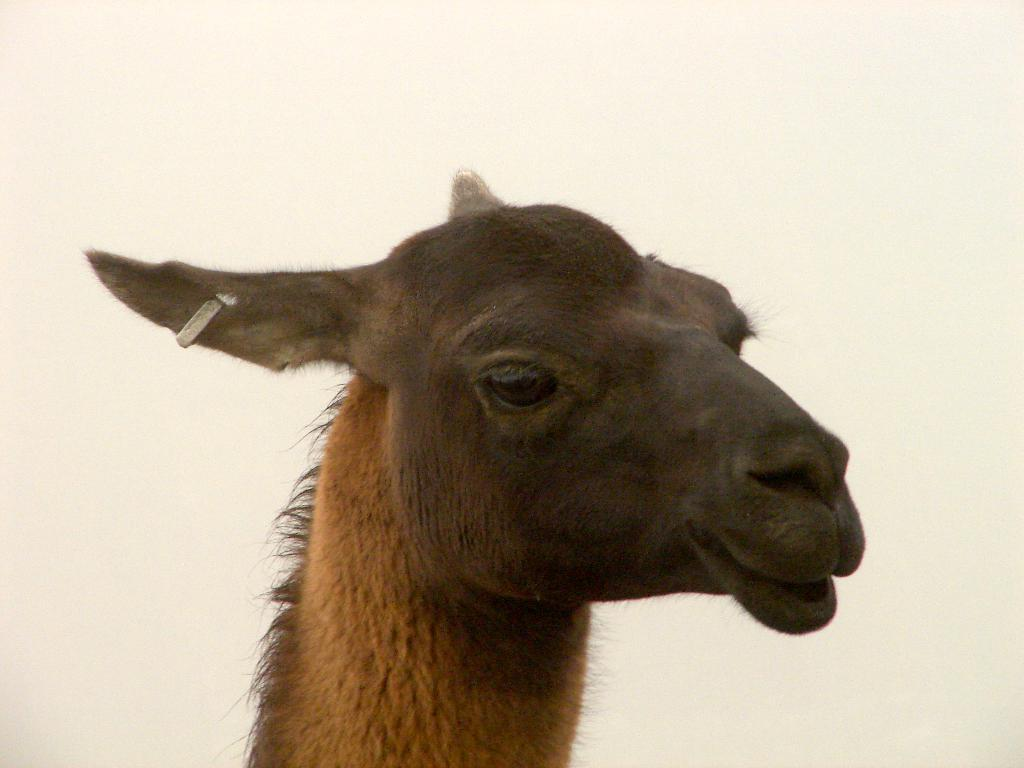What type of animal is present in the image? There is an animal in the image, but the specific type cannot be determined from the provided facts. What unique feature can be seen on the animal? The animal has an earring in its ear. Can you describe how the animal talks in the image? There is no indication in the image that the animal is talking, so it cannot be determined from the picture. 